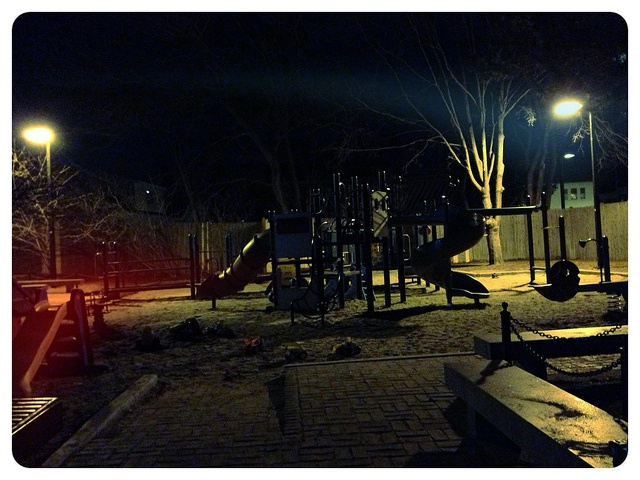Describe the objects in this image and their specific colors. I can see bench in white, black, olive, darkgreen, and tan tones and bench in white, black, khaki, olive, and darkgreen tones in this image. 